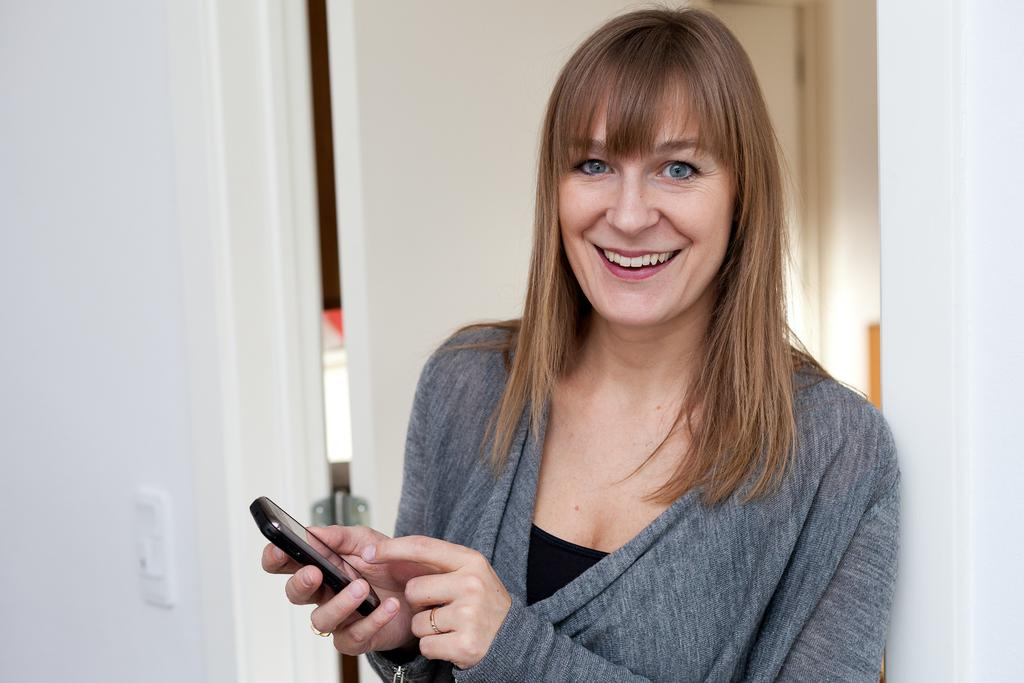What is the lady doing on the right side of the image? The lady is standing on the right side of the image. What is the lady holding in her hand? The lady is holding a mobile in her hand. What expression does the lady have on her face? The lady is smiling. What can be seen in the background of the image? There is a door and a wall in the background of the image. What type of metal is the lady observing in the image? There is no metal present in the image for the lady to observe. 